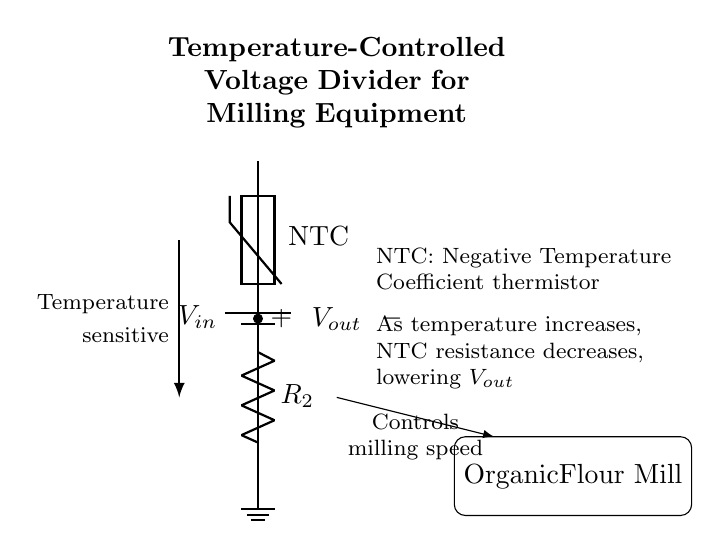What is the input voltage in this circuit? The input voltage is indicated by the label on the battery symbol, which provides the power source to the circuit.
Answer: V in What component is used to measure temperature? The component responsible for temperature measurement in this circuit is a thermistor. It is indicated in the diagram as an NTC thermistor. NTC stands for negative temperature coefficient, which means its resistance decreases as temperature increases.
Answer: NTC thermistor What happens to the output voltage as temperature increases? The output voltage decreases as the temperature increases due to the nature of the NTC thermistor. When the temperature rises, the resistance of the thermistor falls, leading to a reduction in the output voltage across the resistor.
Answer: Decreases What is the role of the fixed resistor in this circuit? The fixed resistor, denoted as R2, forms part of the voltage divider circuit. Its value helps set the output voltage based on the input voltage and the resistance of the NTC thermistor, thus regulating the output based on temperature changes.
Answer: Voltage divider How does this circuit affect milling equipment? The circuit controls the milling speed by adjusting the output voltage based on the temperature measured by the thermistor, which in turn influences how the milling equipment operates at different temperatures for optimal performance.
Answer: Controls milling speed What is the purpose of the ground in this circuit? The ground serves as a reference point for the entire circuit, completing the electrical pathway and ensuring that all voltage levels referenced in the circuit diagram are stable relative to this common point.
Answer: Reference point 